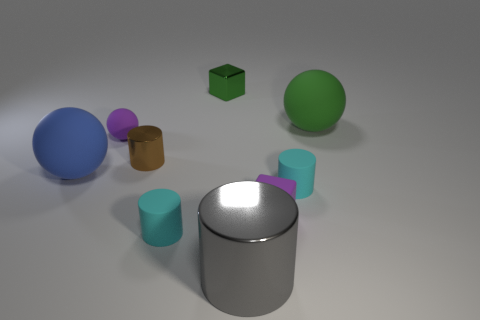What number of rubber things are tiny spheres or cyan objects?
Keep it short and to the point. 3. Is the number of cyan matte blocks less than the number of tiny cyan cylinders?
Your response must be concise. Yes. There is a purple rubber block; is its size the same as the metallic object that is behind the green rubber thing?
Offer a very short reply. Yes. Is there any other thing that has the same shape as the brown object?
Offer a terse response. Yes. What size is the gray thing?
Offer a terse response. Large. Is the number of tiny rubber things that are in front of the large cylinder less than the number of tiny brown metallic cylinders?
Your response must be concise. Yes. Do the green metal thing and the gray metallic cylinder have the same size?
Offer a terse response. No. Is there anything else that has the same size as the blue sphere?
Keep it short and to the point. Yes. What is the color of the small cylinder that is the same material as the tiny green block?
Offer a terse response. Brown. Are there fewer large blue spheres that are to the right of the gray thing than blue matte balls that are behind the tiny matte ball?
Ensure brevity in your answer.  No. 